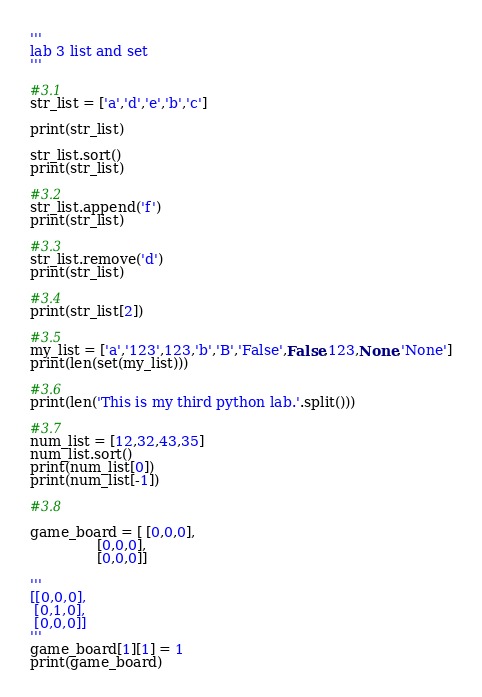Convert code to text. <code><loc_0><loc_0><loc_500><loc_500><_Python_>'''
lab 3 list and set
'''

#3.1
str_list = ['a','d','e','b','c']

print(str_list)

str_list.sort()
print(str_list)

#3.2
str_list.append('f')
print(str_list)

#3.3
str_list.remove('d')
print(str_list)

#3.4
print(str_list[2])

#3.5
my_list = ['a','123',123,'b','B','False',False,123,None,'None']
print(len(set(my_list)))

#3.6
print(len('This is my third python lab.'.split()))

#3.7
num_list = [12,32,43,35]
num_list.sort()
print(num_list[0])
print(num_list[-1])

#3.8

game_board = [ [0,0,0],
               [0,0,0],
               [0,0,0]]
              
'''
[[0,0,0],
 [0,1,0],
 [0,0,0]]
'''
game_board[1][1] = 1
print(game_board)</code> 